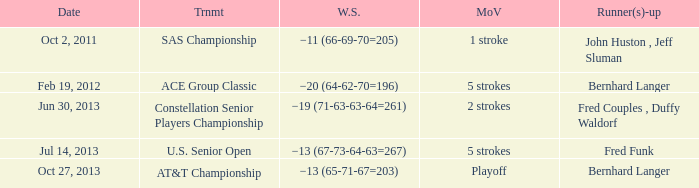Which contest occurred on july 14, 2013? U.S. Senior Open. 